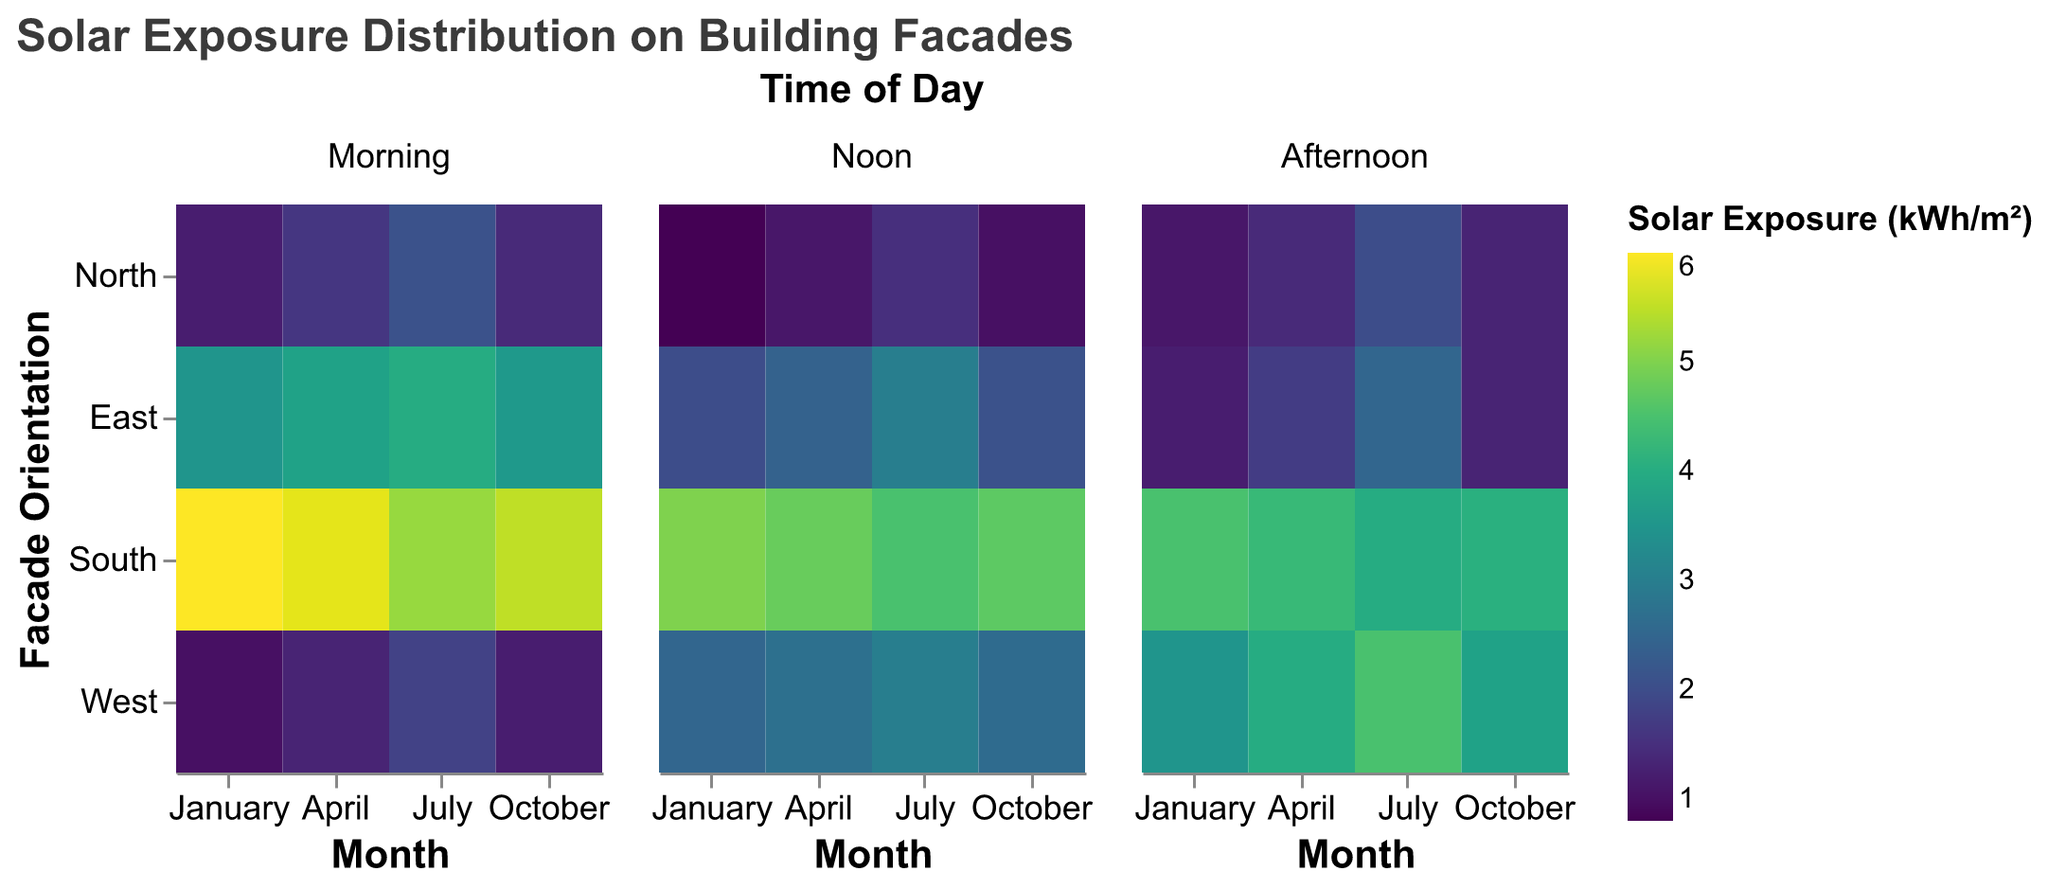What is the title of the figure? The title of the figure is usually displayed at the top of the chart. In this case, it is stated in the title section of the visualization schema.
Answer: "Solar Exposure Distribution on Building Facades" Which facade orientation has the highest morning solar exposure in July? Check the heatmap for the 'Morning' time of day and observe the color intensity for each orientation in July. The South orientation has the highest value of 5.2.
Answer: South Which month sees the lowest noon solar exposure for the North facade? To find the lowest noon solar exposure for the North facade, look at the 'Noon' time of day for all months for the North orientation. January has the lowest value of 0.8.
Answer: January What is the afternoon solar exposure for the West facade in October? Locate the West orientation in October in the 'Afternoon' time of day facet. The value is indicated directly in the data.
Answer: 3.8 Compare the morning solar exposure between the East and West facades in April. Which one is higher and by how much? Check the values for the East and West facades in the 'Morning' time of day for April. East has 3.8 kWh/m² and West has 1.3 kWh/m². Calculate the difference: 3.8 - 1.3 = 2.5 kWh/m².
Answer: East is higher by 2.5 kWh/m² On average, which orientation receives the highest solar exposure at noon throughout the year? Calculate the average noon solar exposure for each orientation by summing their noon values across all months and dividing by the number of months. South has the highest average: (5.0 + 4.8 + 4.5 + 4.7) / 4 = 4.75 kWh/m².
Answer: South Considering all times of the day, which month has the highest solar exposure for the South facade? Find the sum of the morning, noon, and afternoon values for the South facade for each month. For January: 6.0 + 5.0 + 4.5 = 15.5; For April: 5.8 + 4.8 + 4.3 = 14.9; For July: 5.2 + 4.5 + 4.0 = 13.7; For October: 5.5 + 4.7 + 4.1 = 14.3. January has the highest total.
Answer: January Which time of day typically sees the greatest solar exposure for the East facade? Compare the average solar exposure values for the East facade across different times of day by summing values for each time and dividing by the number of months. The average for Morning is (3.5 + 3.8 + 4.0 + 3.6) / 4 = 3.725, for Noon is (2.0 + 2.4 + 3.0 + 2.1) / 4 = 2.375, and for Afternoon is (1.2 + 1.7 + 2.5 + 1.3) / 4 = 1.675. Morning has the highest value.
Answer: Morning 